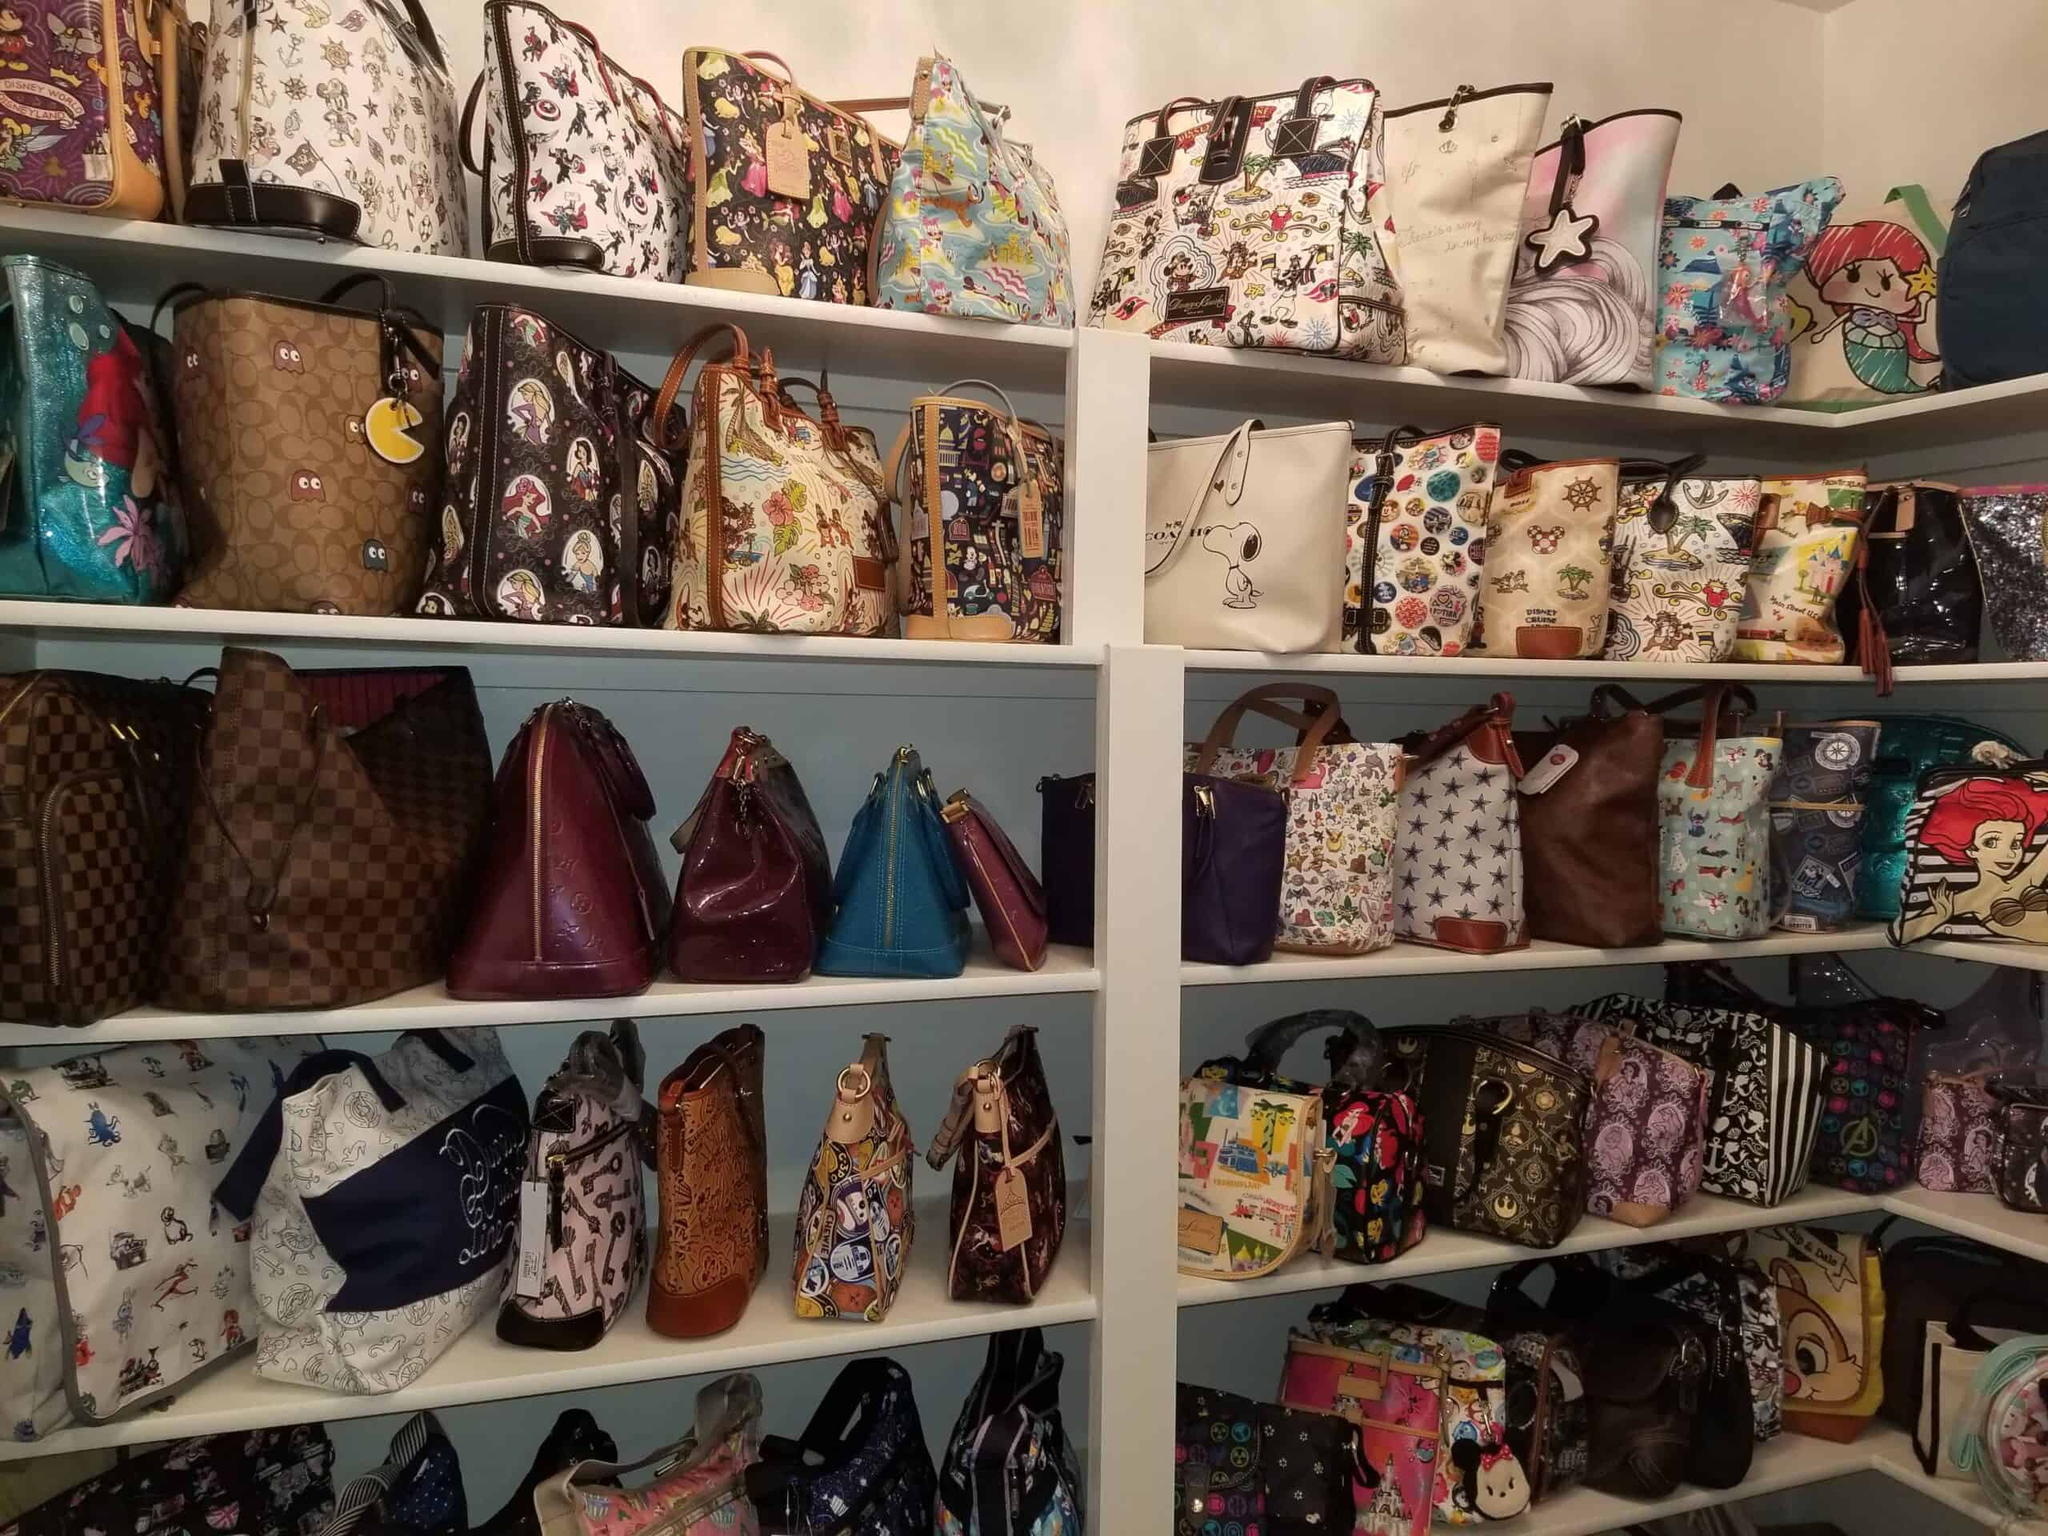What is the dominant color scheme or pattern type among the bags displayed? The dominant pattern and color scheme among the bags displayed predominantly features vibrant, themed designs that incorporate cartoon characters and pop culture references. The eclectic mix includes both colorful and detailed imagery that makes each bag stand out. This collection likely appeals to fans of animated themes and popular media, showcasing a visually striking and playful assortment. 